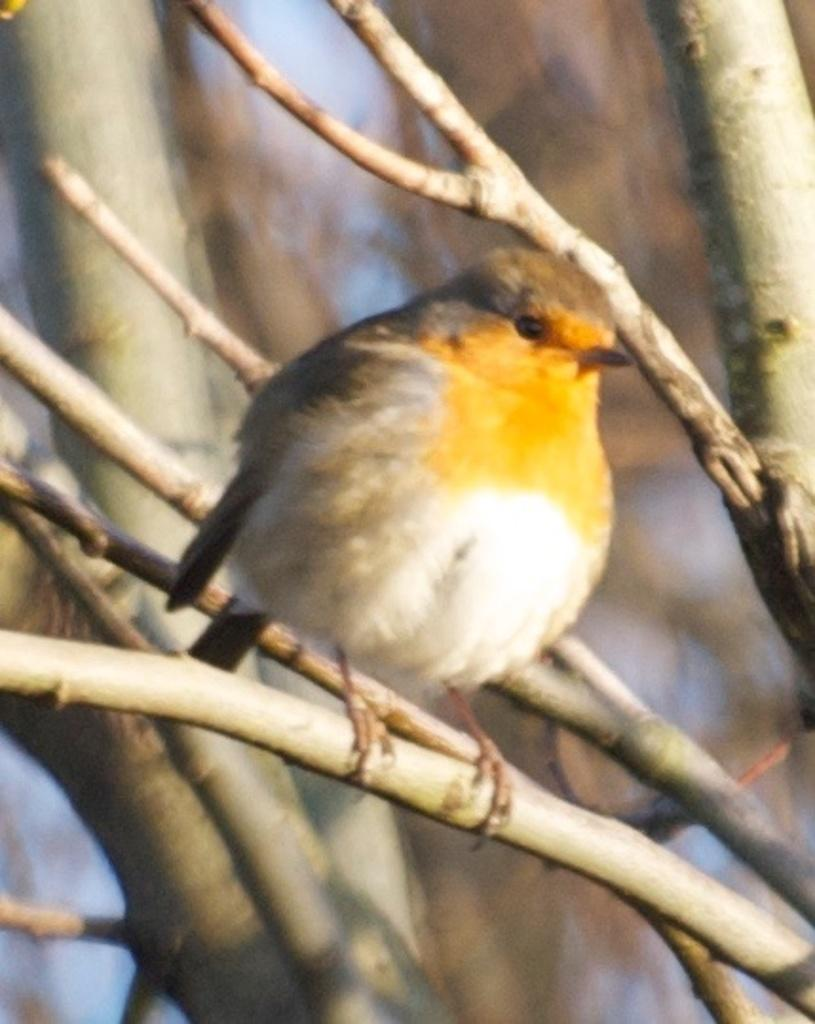What type of animal can be seen in the image? There is a bird in the image. Where is the bird located? The bird is on a tree. What can be seen in the background of the image? There are trees in the background of the image. What type of door can be seen in the image? There is no door present in the image; it features a bird on a tree and trees in the background. 